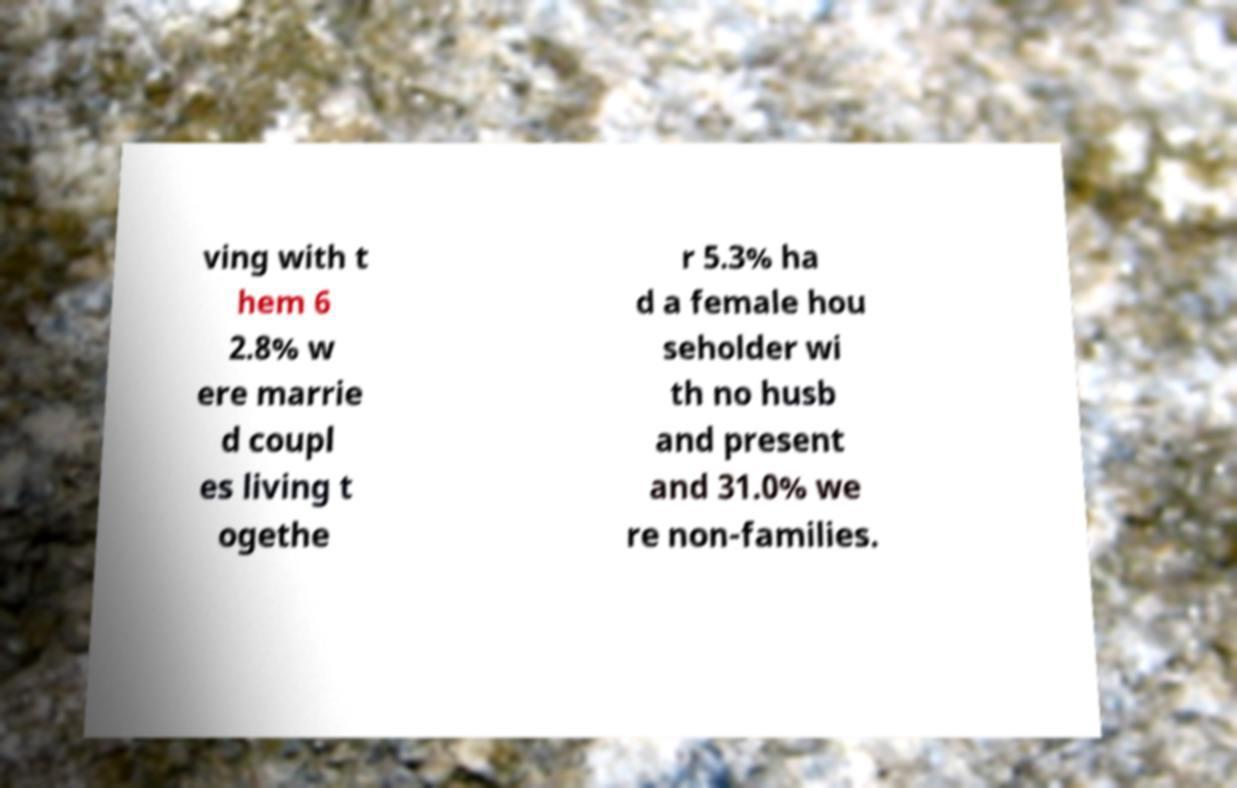Can you accurately transcribe the text from the provided image for me? ving with t hem 6 2.8% w ere marrie d coupl es living t ogethe r 5.3% ha d a female hou seholder wi th no husb and present and 31.0% we re non-families. 